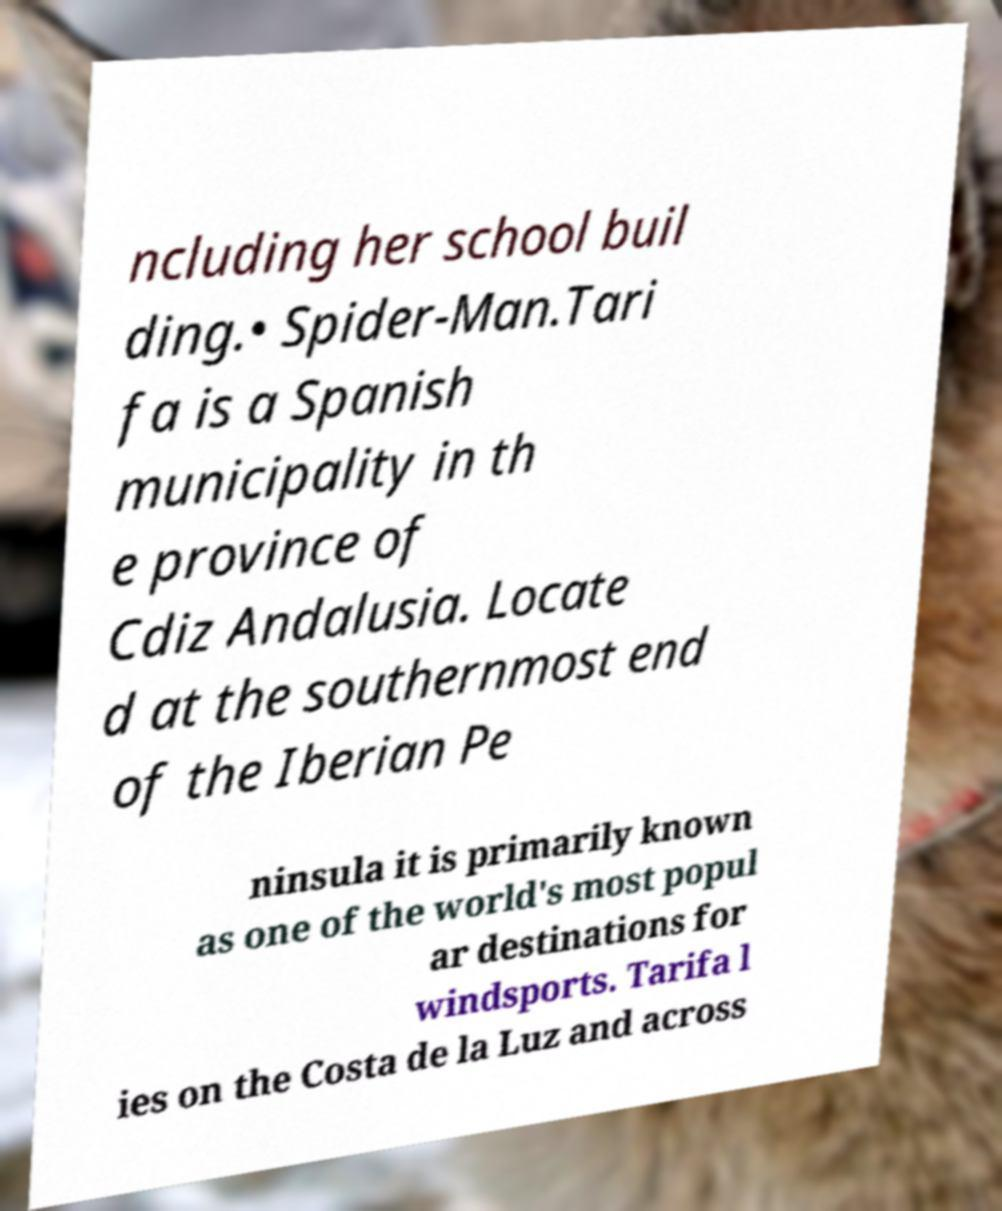I need the written content from this picture converted into text. Can you do that? ncluding her school buil ding.• Spider-Man.Tari fa is a Spanish municipality in th e province of Cdiz Andalusia. Locate d at the southernmost end of the Iberian Pe ninsula it is primarily known as one of the world's most popul ar destinations for windsports. Tarifa l ies on the Costa de la Luz and across 